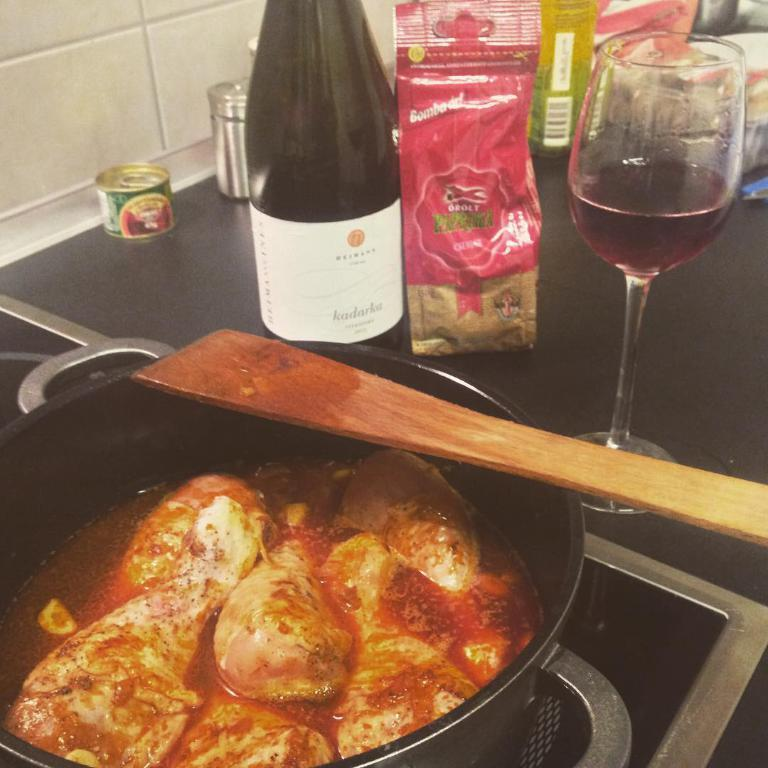What type of cooking appliance is in the image? There is a gas stove in the image. What is on top of the gas stove? There is a bowl with food on the gas stove. What is inside the bowl with food? There is a stick in the bowl. What else is beside the gas stove? There is a bottle and a glass with liquid beside the gas stove, as well as food packets. What type of actor is standing in the yard beside the gas stove in the image? There is no actor or yard present in the image; it features a gas stove with a bowl of food and other items. What type of laborer is working on the gas stove in the image? There is no laborer present in the image; it features a gas stove with a bowl of food and other items. 